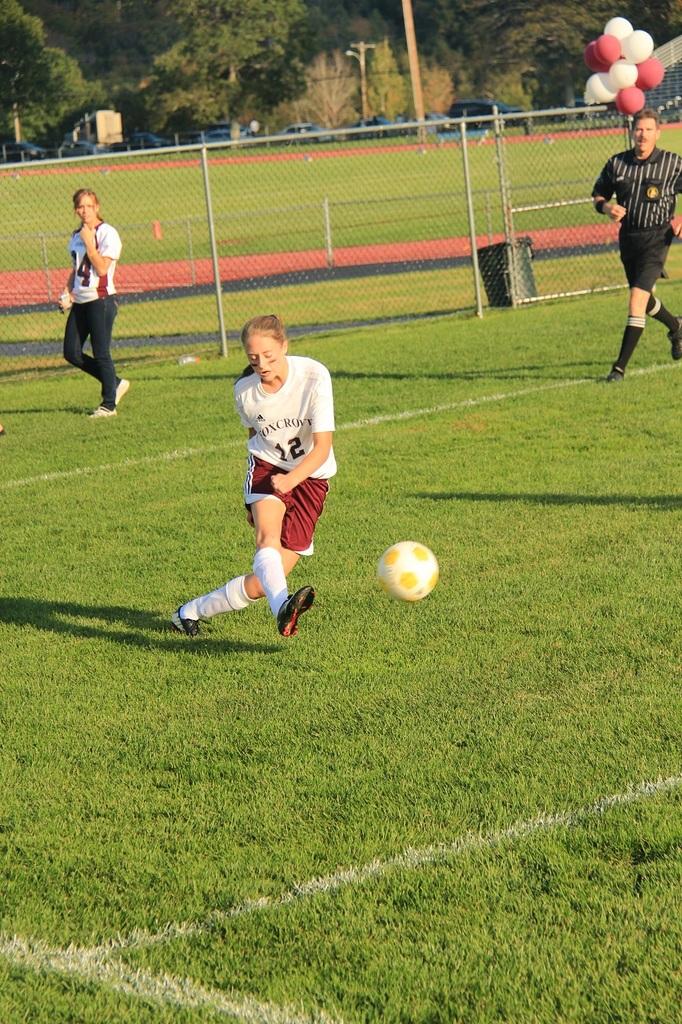What's her jersey number?
Your answer should be very brief. 12. What number is the player on the left?
Ensure brevity in your answer.  14. 